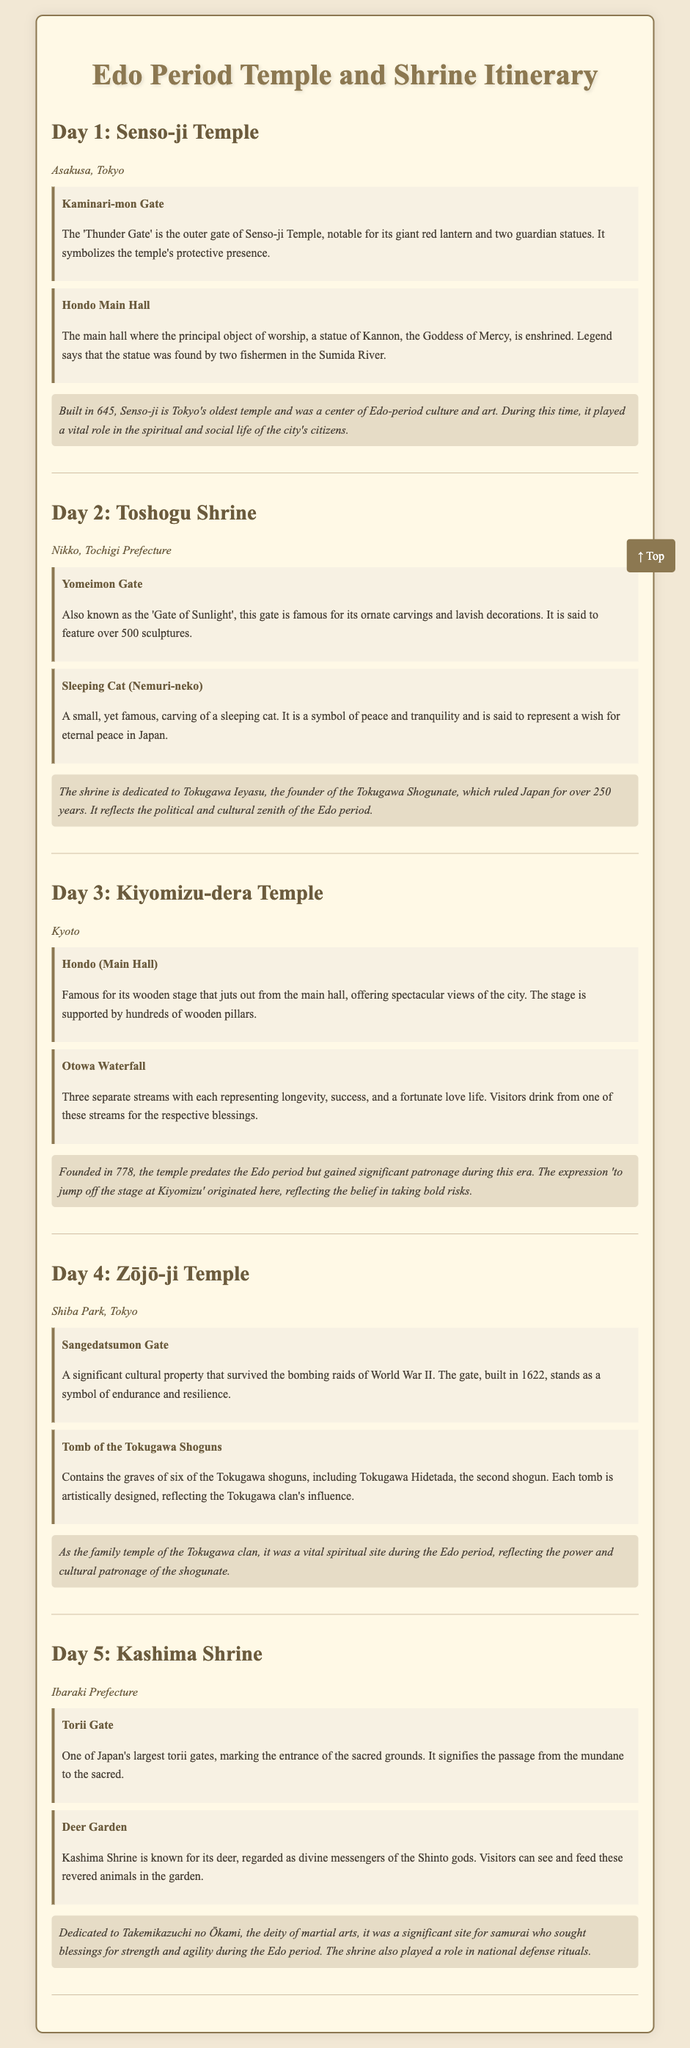What is the location of Senso-ji Temple? Senso-ji Temple is located in Asakusa, Tokyo.
Answer: Asakusa, Tokyo What is the main deity enshrined in the Hondo Main Hall of Senso-ji Temple? The Hondo Main Hall enshrines a statue of Kannon, the Goddess of Mercy.
Answer: Kannon What year was Toshogu Shrine built? Toshogu Shrine is dedicated to Tokugawa Ieyasu and reflects the political zenith of the Edo period, implying construction took place in the early Edo period.
Answer: 250 years Which significant gate is known for its ornate carvings at Toshogu Shrine? The Yomeimon Gate is famed for its ornate carvings and lavish decorations.
Answer: Yomeimon Gate How many streams are there at Otowa Waterfall in Kiyomizu-dera Temple? Visitors can drink from three separate streams, each representing different blessings.
Answer: Three What was Zōjō-ji Temple used for during the Edo period? Zōjō-ji Temple served as the family temple of the Tokugawa clan, highlighting its spiritual significance.
Answer: Family temple What is the historical significance of Kashima Shrine? Kashima Shrine is dedicated to Takemikazuchi no Ōkami, a deity of martial arts, significant for samurai seeking blessings during the Edo period.
Answer: Samurai blessings 